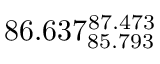Convert formula to latex. <formula><loc_0><loc_0><loc_500><loc_500>8 6 . 6 3 7 _ { 8 5 . 7 9 3 } ^ { 8 7 . 4 7 3 }</formula> 